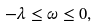Convert formula to latex. <formula><loc_0><loc_0><loc_500><loc_500>- \lambda \leq \omega \leq 0 ,</formula> 